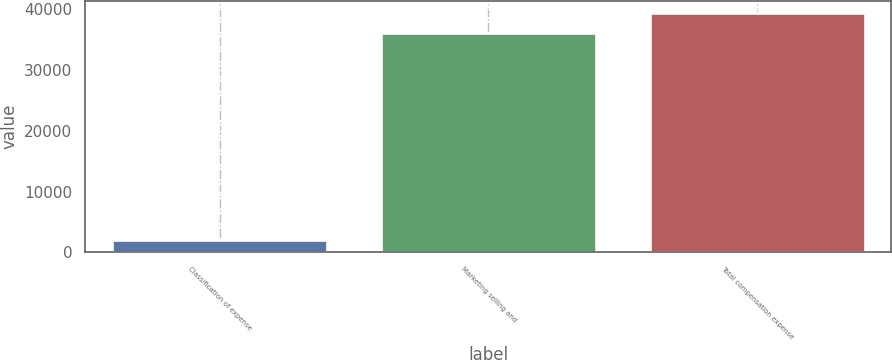Convert chart to OTSL. <chart><loc_0><loc_0><loc_500><loc_500><bar_chart><fcel>Classification of expense<fcel>Marketing selling and<fcel>Total compensation expense<nl><fcel>2015<fcel>36073<fcel>39478.8<nl></chart> 